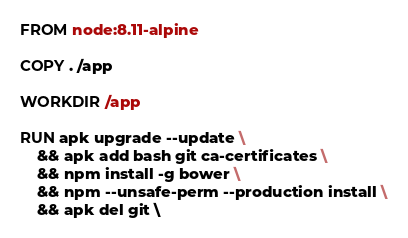Convert code to text. <code><loc_0><loc_0><loc_500><loc_500><_Dockerfile_>FROM node:8.11-alpine

COPY . /app

WORKDIR /app

RUN apk upgrade --update \
    && apk add bash git ca-certificates \
    && npm install -g bower \
    && npm --unsafe-perm --production install \
    && apk del git \</code> 